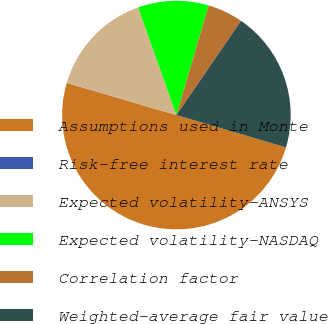<chart> <loc_0><loc_0><loc_500><loc_500><pie_chart><fcel>Assumptions used in Monte<fcel>Risk-free interest rate<fcel>Expected volatility-ANSYS<fcel>Expected volatility-NASDAQ<fcel>Correlation factor<fcel>Weighted-average fair value<nl><fcel>49.97%<fcel>0.02%<fcel>15.0%<fcel>10.01%<fcel>5.01%<fcel>20.0%<nl></chart> 